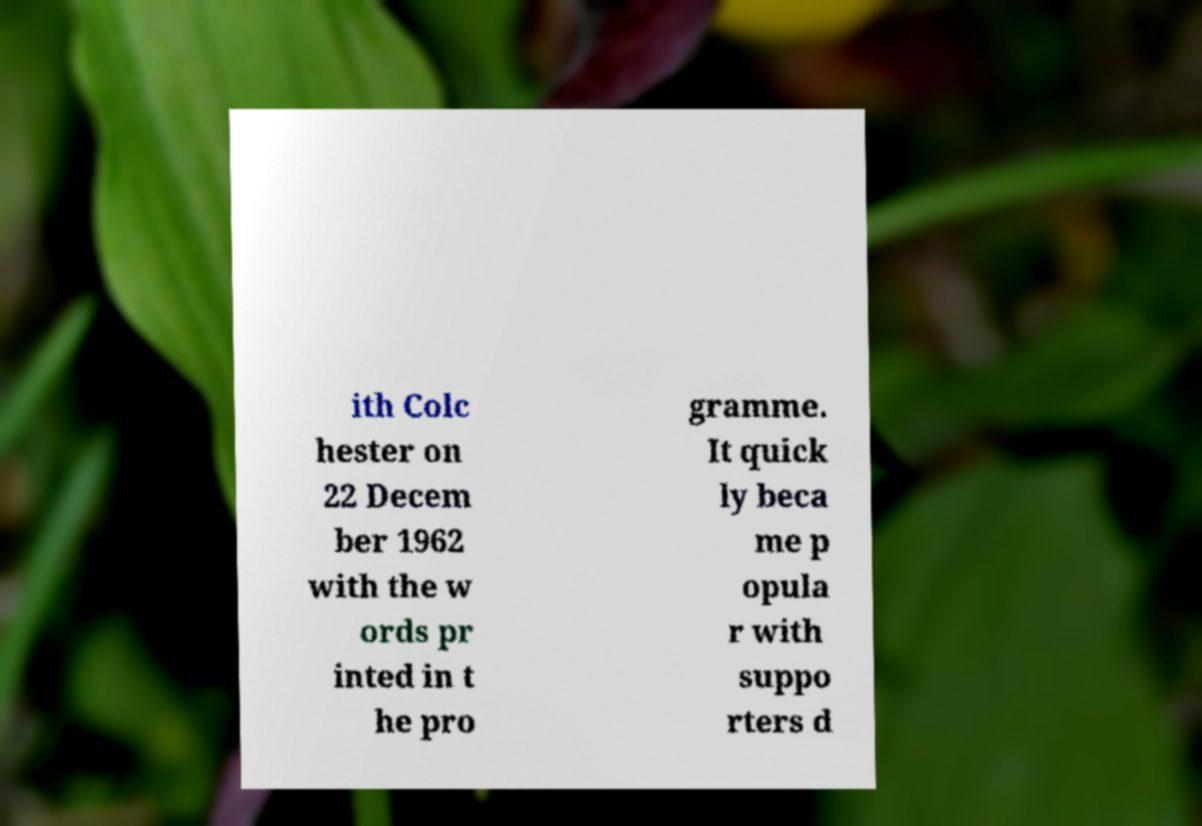Please read and relay the text visible in this image. What does it say? ith Colc hester on 22 Decem ber 1962 with the w ords pr inted in t he pro gramme. It quick ly beca me p opula r with suppo rters d 